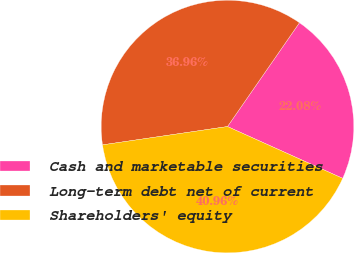Convert chart. <chart><loc_0><loc_0><loc_500><loc_500><pie_chart><fcel>Cash and marketable securities<fcel>Long-term debt net of current<fcel>Shareholders' equity<nl><fcel>22.08%<fcel>36.96%<fcel>40.96%<nl></chart> 